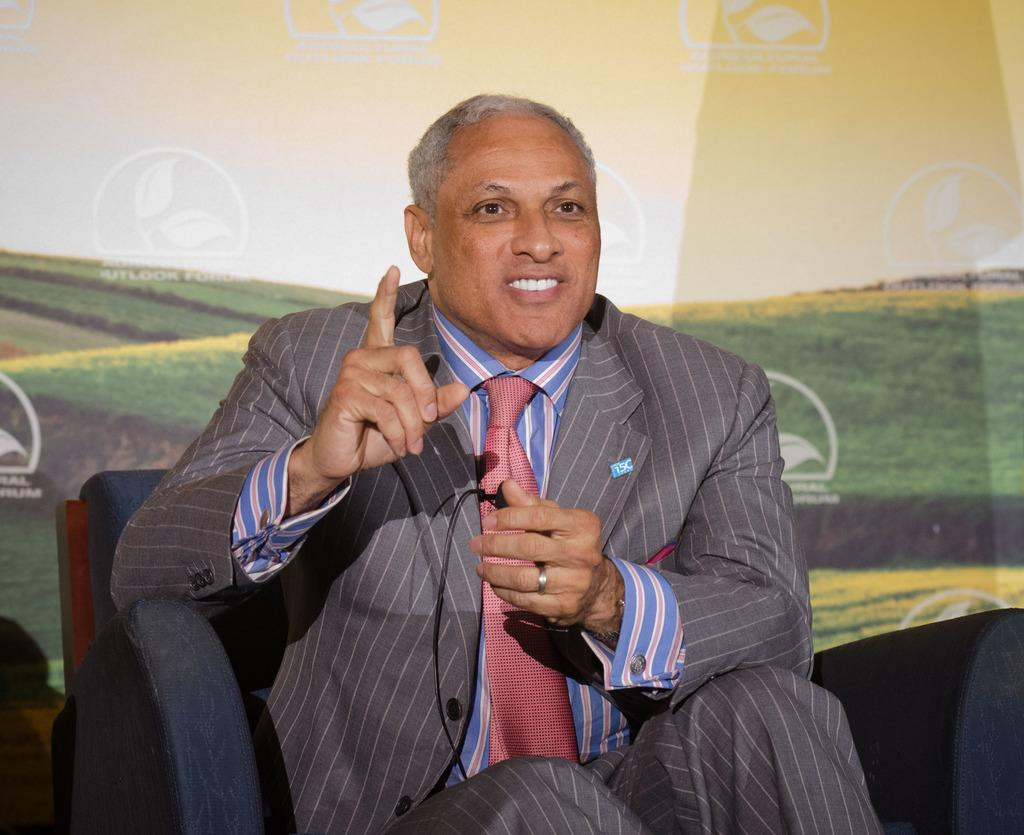Who is the main subject in the image? There is a man in the image. What is the man doing in the image? The man is sitting in the center on a sofa and holding a mic in his hand. What is the man's facial expression in the image? The man is smiling in the image. What can be seen in the background of the image? There is a banner in the background of the image. What is written on the banner? The banner has text written on it. Can you tell me how many times the man kicks the crib in the image? There is no crib present in the image, and therefore no kicking can be observed. What type of approval does the man receive from the audience in the image? The image does not show any audience or indication of approval, so it cannot be determined from the image. 